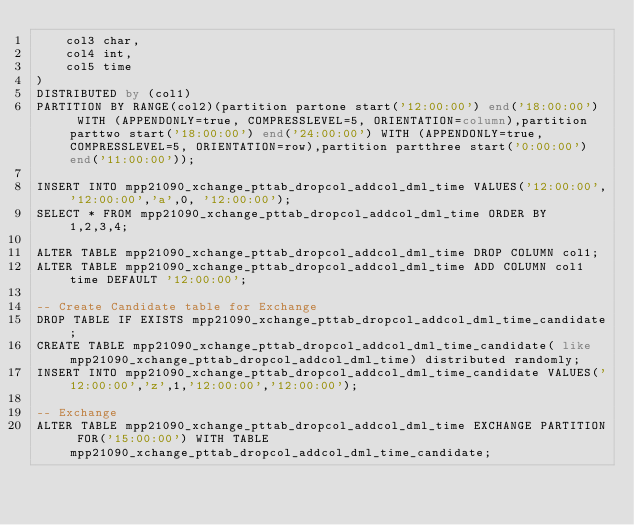Convert code to text. <code><loc_0><loc_0><loc_500><loc_500><_SQL_>    col3 char,
    col4 int,
    col5 time
) 
DISTRIBUTED by (col1)
PARTITION BY RANGE(col2)(partition partone start('12:00:00') end('18:00:00')  WITH (APPENDONLY=true, COMPRESSLEVEL=5, ORIENTATION=column),partition parttwo start('18:00:00') end('24:00:00') WITH (APPENDONLY=true, COMPRESSLEVEL=5, ORIENTATION=row),partition partthree start('0:00:00') end('11:00:00'));

INSERT INTO mpp21090_xchange_pttab_dropcol_addcol_dml_time VALUES('12:00:00','12:00:00','a',0, '12:00:00');
SELECT * FROM mpp21090_xchange_pttab_dropcol_addcol_dml_time ORDER BY 1,2,3,4;

ALTER TABLE mpp21090_xchange_pttab_dropcol_addcol_dml_time DROP COLUMN col1;
ALTER TABLE mpp21090_xchange_pttab_dropcol_addcol_dml_time ADD COLUMN col1 time DEFAULT '12:00:00';

-- Create Candidate table for Exchange
DROP TABLE IF EXISTS mpp21090_xchange_pttab_dropcol_addcol_dml_time_candidate;
CREATE TABLE mpp21090_xchange_pttab_dropcol_addcol_dml_time_candidate( like mpp21090_xchange_pttab_dropcol_addcol_dml_time) distributed randomly;
INSERT INTO mpp21090_xchange_pttab_dropcol_addcol_dml_time_candidate VALUES('12:00:00','z',1,'12:00:00','12:00:00');

-- Exchange 
ALTER TABLE mpp21090_xchange_pttab_dropcol_addcol_dml_time EXCHANGE PARTITION FOR('15:00:00') WITH TABLE mpp21090_xchange_pttab_dropcol_addcol_dml_time_candidate;
</code> 